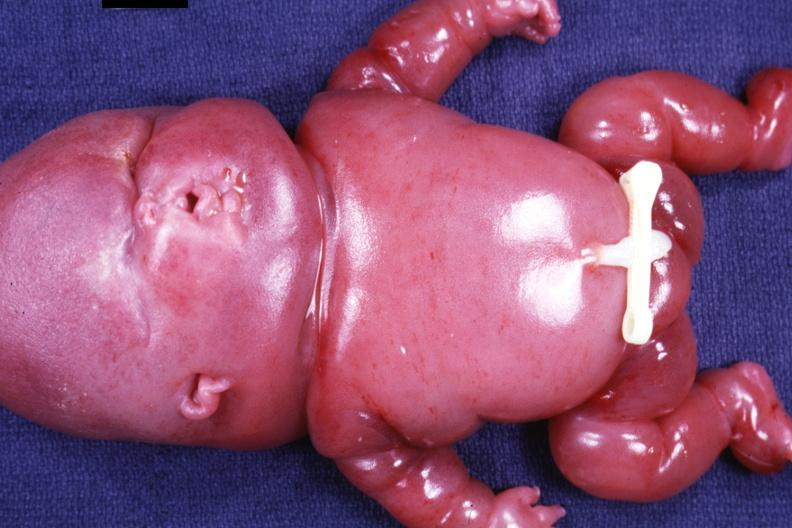what does this image show?
Answer the question using a single word or phrase. Anterior view of whole body 